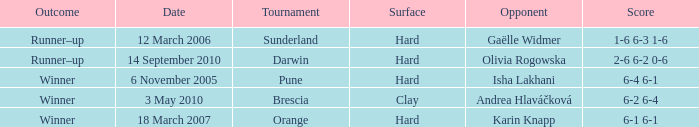When was the tournament at Orange? 18 March 2007. Could you parse the entire table? {'header': ['Outcome', 'Date', 'Tournament', 'Surface', 'Opponent', 'Score'], 'rows': [['Runner–up', '12 March 2006', 'Sunderland', 'Hard', 'Gaëlle Widmer', '1-6 6-3 1-6'], ['Runner–up', '14 September 2010', 'Darwin', 'Hard', 'Olivia Rogowska', '2-6 6-2 0-6'], ['Winner', '6 November 2005', 'Pune', 'Hard', 'Isha Lakhani', '6-4 6-1'], ['Winner', '3 May 2010', 'Brescia', 'Clay', 'Andrea Hlaváčková', '6-2 6-4'], ['Winner', '18 March 2007', 'Orange', 'Hard', 'Karin Knapp', '6-1 6-1']]} 